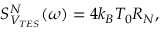Convert formula to latex. <formula><loc_0><loc_0><loc_500><loc_500>S _ { V _ { T E S } } ^ { N } ( \omega ) = 4 k _ { B } T _ { 0 } R _ { N } ,</formula> 